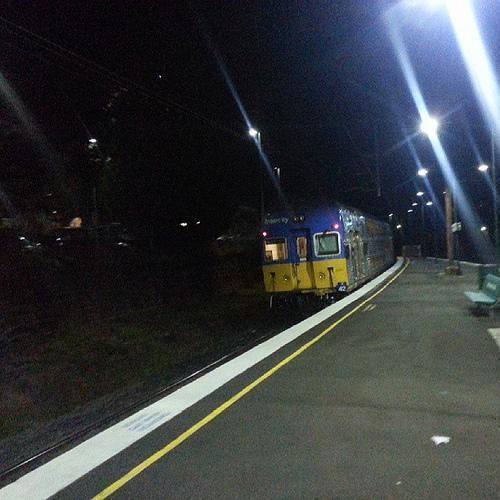How many trains are in the photo?
Give a very brief answer. 1. 